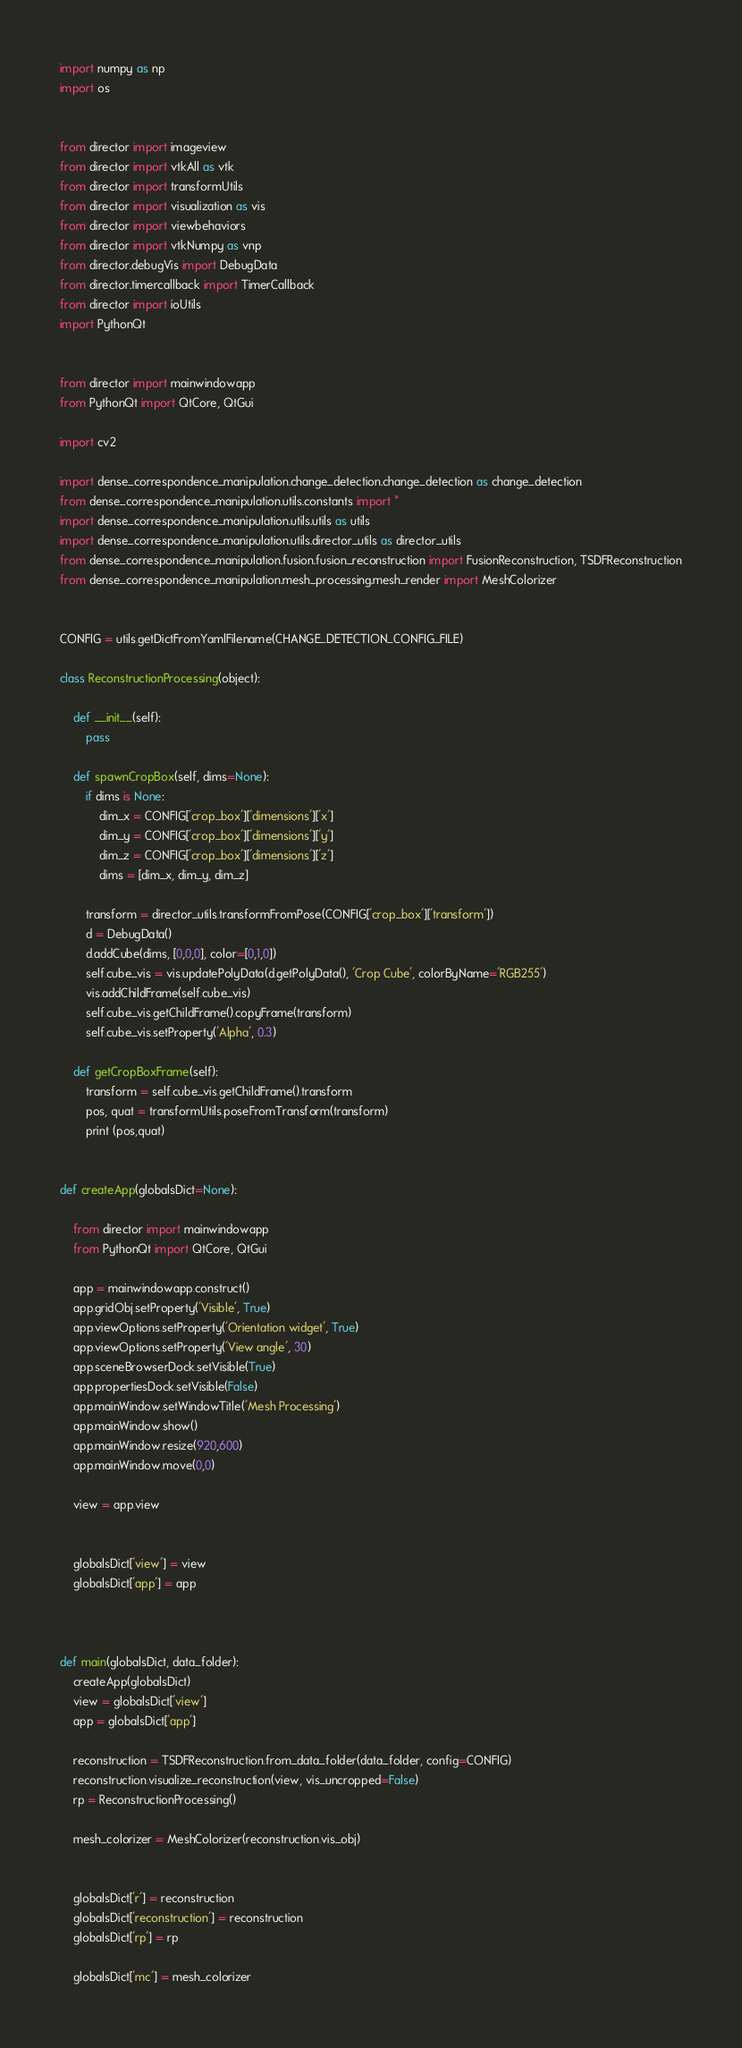<code> <loc_0><loc_0><loc_500><loc_500><_Python_>import numpy as np
import os


from director import imageview
from director import vtkAll as vtk
from director import transformUtils
from director import visualization as vis
from director import viewbehaviors
from director import vtkNumpy as vnp
from director.debugVis import DebugData
from director.timercallback import TimerCallback
from director import ioUtils
import PythonQt


from director import mainwindowapp
from PythonQt import QtCore, QtGui

import cv2

import dense_correspondence_manipulation.change_detection.change_detection as change_detection
from dense_correspondence_manipulation.utils.constants import *
import dense_correspondence_manipulation.utils.utils as utils
import dense_correspondence_manipulation.utils.director_utils as director_utils
from dense_correspondence_manipulation.fusion.fusion_reconstruction import FusionReconstruction, TSDFReconstruction
from dense_correspondence_manipulation.mesh_processing.mesh_render import MeshColorizer


CONFIG = utils.getDictFromYamlFilename(CHANGE_DETECTION_CONFIG_FILE)

class ReconstructionProcessing(object):

    def __init__(self):
        pass

    def spawnCropBox(self, dims=None):
        if dims is None:
            dim_x = CONFIG['crop_box']['dimensions']['x']
            dim_y = CONFIG['crop_box']['dimensions']['y']
            dim_z = CONFIG['crop_box']['dimensions']['z']
            dims = [dim_x, dim_y, dim_z]

        transform = director_utils.transformFromPose(CONFIG['crop_box']['transform'])
        d = DebugData()
        d.addCube(dims, [0,0,0], color=[0,1,0])
        self.cube_vis = vis.updatePolyData(d.getPolyData(), 'Crop Cube', colorByName='RGB255')
        vis.addChildFrame(self.cube_vis)
        self.cube_vis.getChildFrame().copyFrame(transform)
        self.cube_vis.setProperty('Alpha', 0.3)

    def getCropBoxFrame(self):
        transform = self.cube_vis.getChildFrame().transform
        pos, quat = transformUtils.poseFromTransform(transform)
        print (pos,quat)


def createApp(globalsDict=None):

    from director import mainwindowapp
    from PythonQt import QtCore, QtGui

    app = mainwindowapp.construct()
    app.gridObj.setProperty('Visible', True)
    app.viewOptions.setProperty('Orientation widget', True)
    app.viewOptions.setProperty('View angle', 30)
    app.sceneBrowserDock.setVisible(True)
    app.propertiesDock.setVisible(False)
    app.mainWindow.setWindowTitle('Mesh Processing')
    app.mainWindow.show()
    app.mainWindow.resize(920,600)
    app.mainWindow.move(0,0)

    view = app.view


    globalsDict['view'] = view
    globalsDict['app'] = app



def main(globalsDict, data_folder):
    createApp(globalsDict)
    view = globalsDict['view']
    app = globalsDict['app']

    reconstruction = TSDFReconstruction.from_data_folder(data_folder, config=CONFIG)
    reconstruction.visualize_reconstruction(view, vis_uncropped=False)
    rp = ReconstructionProcessing()

    mesh_colorizer = MeshColorizer(reconstruction.vis_obj)


    globalsDict['r'] = reconstruction
    globalsDict['reconstruction'] = reconstruction
    globalsDict['rp'] = rp

    globalsDict['mc'] = mesh_colorizer</code> 